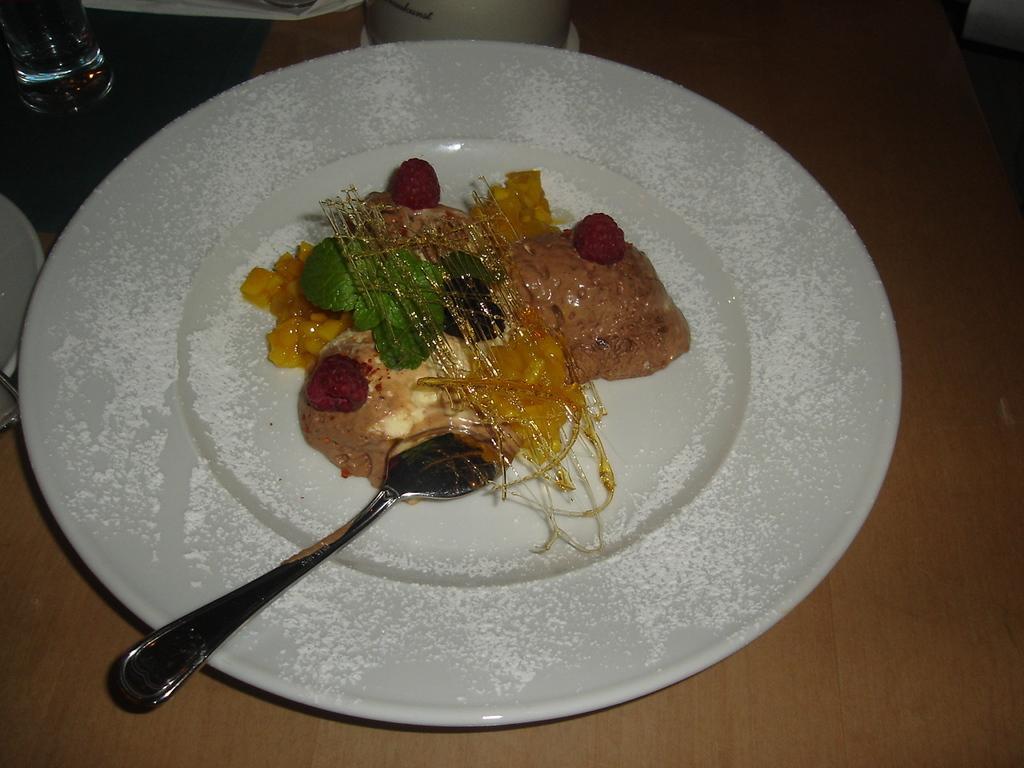How would you summarize this image in a sentence or two? In this image I can see food items and a spoon on a plate. There is a glass at the back. 